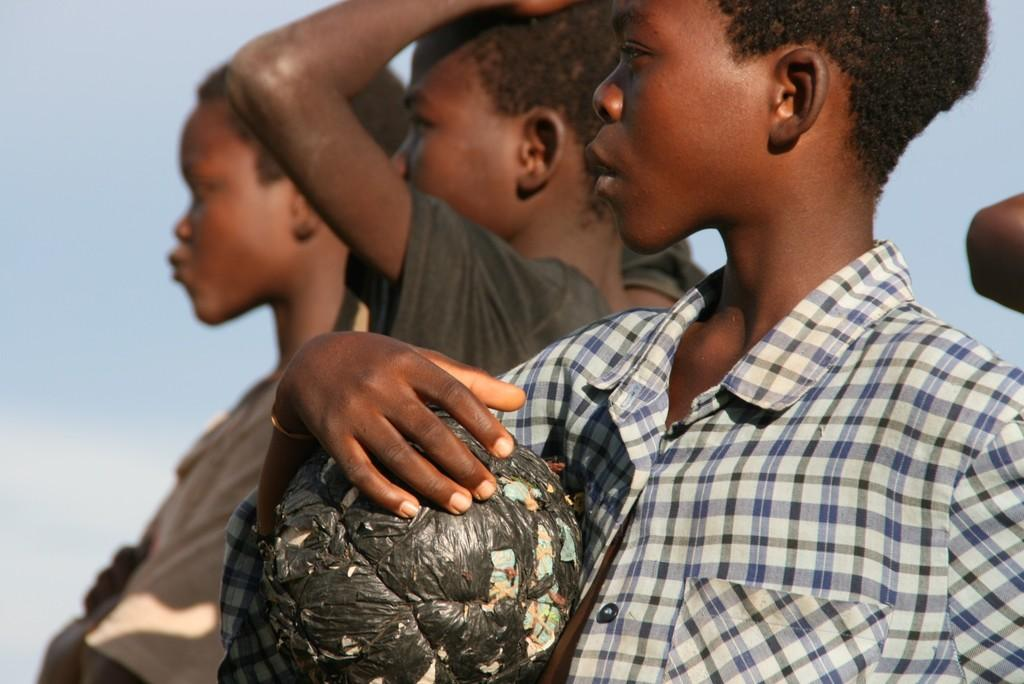How many persons are visible in the image? There are persons standing in the image. Can you describe the position of the boy in the image? The boy is standing in the front. What is the boy holding in the image? The boy is holding an object that is black in color. What is the weather like in the image? The sky is cloudy in the image. Can you tell me how many fangs are visible on the boy in the image? There are no fangs visible on the boy in the image. What type of pan is being used by the persons in the image? There is no pan present in the image. 